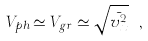<formula> <loc_0><loc_0><loc_500><loc_500>V _ { p h } \simeq V _ { g r } \simeq \sqrt { \bar { v _ { x } ^ { 2 } } } \ ,</formula> 